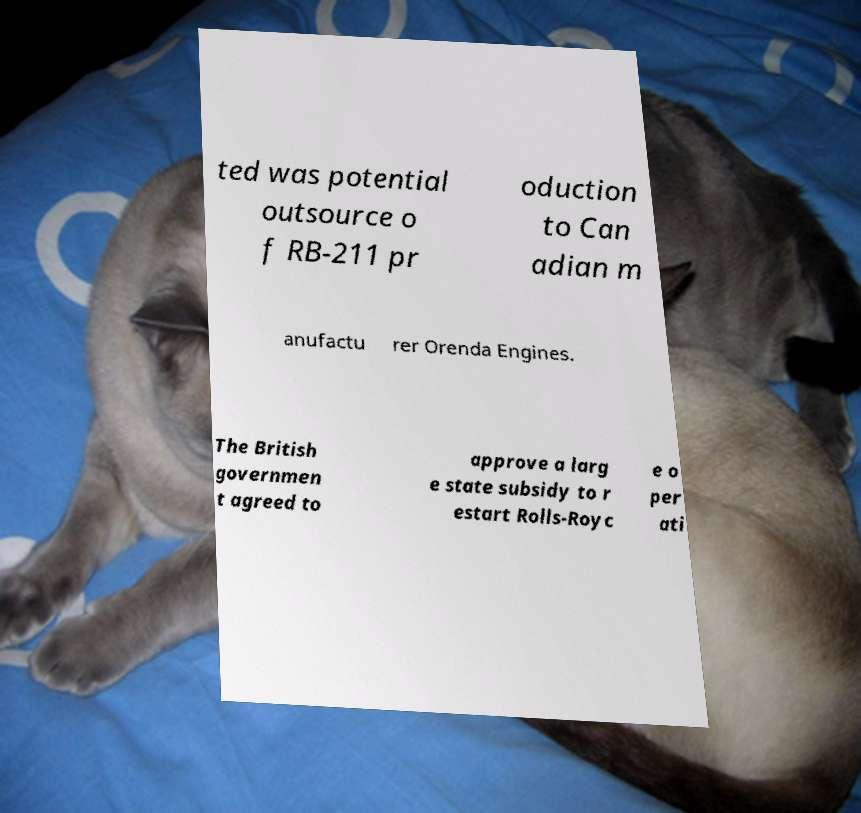For documentation purposes, I need the text within this image transcribed. Could you provide that? ted was potential outsource o f RB-211 pr oduction to Can adian m anufactu rer Orenda Engines. The British governmen t agreed to approve a larg e state subsidy to r estart Rolls-Royc e o per ati 